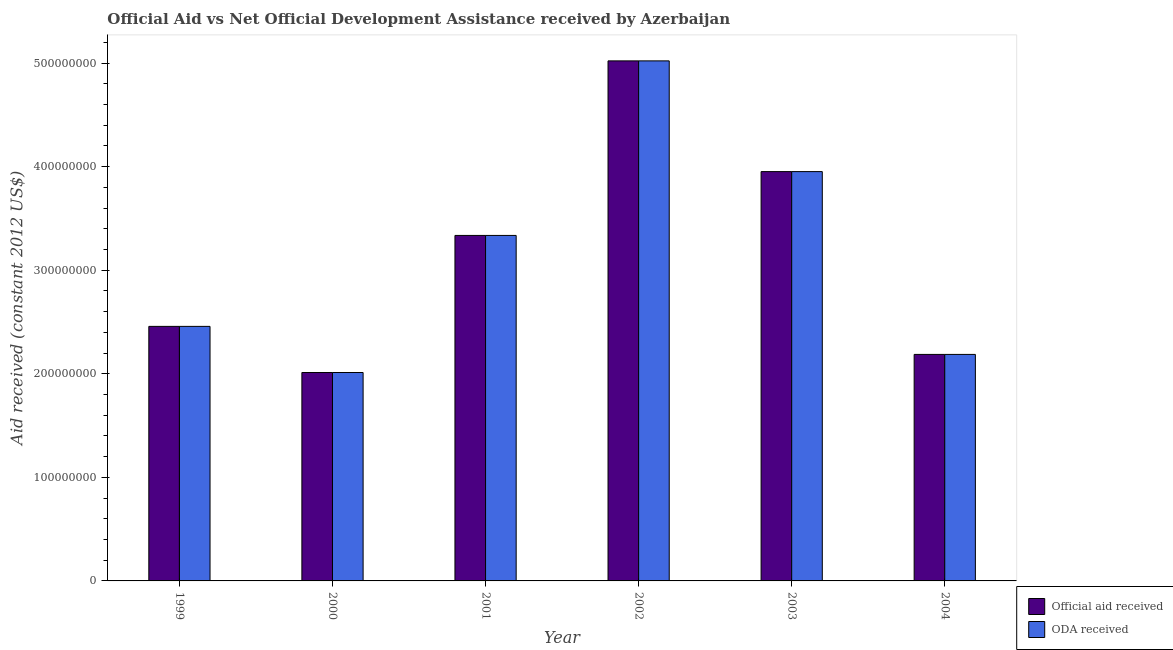How many different coloured bars are there?
Offer a very short reply. 2. How many groups of bars are there?
Provide a succinct answer. 6. Are the number of bars on each tick of the X-axis equal?
Your response must be concise. Yes. How many bars are there on the 5th tick from the left?
Your response must be concise. 2. What is the label of the 3rd group of bars from the left?
Offer a terse response. 2001. In how many cases, is the number of bars for a given year not equal to the number of legend labels?
Your answer should be compact. 0. What is the official aid received in 1999?
Ensure brevity in your answer.  2.46e+08. Across all years, what is the maximum oda received?
Your response must be concise. 5.02e+08. Across all years, what is the minimum official aid received?
Provide a short and direct response. 2.01e+08. In which year was the oda received maximum?
Ensure brevity in your answer.  2002. What is the total official aid received in the graph?
Your answer should be very brief. 1.90e+09. What is the difference between the oda received in 1999 and that in 2004?
Provide a short and direct response. 2.71e+07. What is the difference between the official aid received in 2000 and the oda received in 2001?
Your answer should be very brief. -1.32e+08. What is the average official aid received per year?
Give a very brief answer. 3.16e+08. In the year 2003, what is the difference between the official aid received and oda received?
Provide a succinct answer. 0. In how many years, is the official aid received greater than 160000000 US$?
Give a very brief answer. 6. What is the ratio of the official aid received in 2000 to that in 2001?
Give a very brief answer. 0.6. What is the difference between the highest and the second highest oda received?
Your response must be concise. 1.07e+08. What is the difference between the highest and the lowest official aid received?
Your answer should be compact. 3.01e+08. In how many years, is the oda received greater than the average oda received taken over all years?
Make the answer very short. 3. What does the 1st bar from the left in 2001 represents?
Provide a succinct answer. Official aid received. What does the 2nd bar from the right in 2001 represents?
Your response must be concise. Official aid received. What is the difference between two consecutive major ticks on the Y-axis?
Offer a terse response. 1.00e+08. Does the graph contain any zero values?
Give a very brief answer. No. Where does the legend appear in the graph?
Keep it short and to the point. Bottom right. What is the title of the graph?
Provide a succinct answer. Official Aid vs Net Official Development Assistance received by Azerbaijan . What is the label or title of the X-axis?
Keep it short and to the point. Year. What is the label or title of the Y-axis?
Ensure brevity in your answer.  Aid received (constant 2012 US$). What is the Aid received (constant 2012 US$) of Official aid received in 1999?
Make the answer very short. 2.46e+08. What is the Aid received (constant 2012 US$) of ODA received in 1999?
Your answer should be very brief. 2.46e+08. What is the Aid received (constant 2012 US$) of Official aid received in 2000?
Your response must be concise. 2.01e+08. What is the Aid received (constant 2012 US$) of ODA received in 2000?
Offer a terse response. 2.01e+08. What is the Aid received (constant 2012 US$) of Official aid received in 2001?
Your response must be concise. 3.34e+08. What is the Aid received (constant 2012 US$) in ODA received in 2001?
Keep it short and to the point. 3.34e+08. What is the Aid received (constant 2012 US$) in Official aid received in 2002?
Your answer should be very brief. 5.02e+08. What is the Aid received (constant 2012 US$) in ODA received in 2002?
Give a very brief answer. 5.02e+08. What is the Aid received (constant 2012 US$) in Official aid received in 2003?
Offer a terse response. 3.95e+08. What is the Aid received (constant 2012 US$) of ODA received in 2003?
Keep it short and to the point. 3.95e+08. What is the Aid received (constant 2012 US$) of Official aid received in 2004?
Provide a succinct answer. 2.19e+08. What is the Aid received (constant 2012 US$) in ODA received in 2004?
Make the answer very short. 2.19e+08. Across all years, what is the maximum Aid received (constant 2012 US$) in Official aid received?
Your answer should be compact. 5.02e+08. Across all years, what is the maximum Aid received (constant 2012 US$) of ODA received?
Provide a succinct answer. 5.02e+08. Across all years, what is the minimum Aid received (constant 2012 US$) of Official aid received?
Provide a succinct answer. 2.01e+08. Across all years, what is the minimum Aid received (constant 2012 US$) of ODA received?
Keep it short and to the point. 2.01e+08. What is the total Aid received (constant 2012 US$) in Official aid received in the graph?
Ensure brevity in your answer.  1.90e+09. What is the total Aid received (constant 2012 US$) of ODA received in the graph?
Keep it short and to the point. 1.90e+09. What is the difference between the Aid received (constant 2012 US$) in Official aid received in 1999 and that in 2000?
Offer a very short reply. 4.45e+07. What is the difference between the Aid received (constant 2012 US$) in ODA received in 1999 and that in 2000?
Provide a short and direct response. 4.45e+07. What is the difference between the Aid received (constant 2012 US$) in Official aid received in 1999 and that in 2001?
Your response must be concise. -8.78e+07. What is the difference between the Aid received (constant 2012 US$) of ODA received in 1999 and that in 2001?
Ensure brevity in your answer.  -8.78e+07. What is the difference between the Aid received (constant 2012 US$) of Official aid received in 1999 and that in 2002?
Your response must be concise. -2.56e+08. What is the difference between the Aid received (constant 2012 US$) in ODA received in 1999 and that in 2002?
Your response must be concise. -2.56e+08. What is the difference between the Aid received (constant 2012 US$) of Official aid received in 1999 and that in 2003?
Give a very brief answer. -1.49e+08. What is the difference between the Aid received (constant 2012 US$) of ODA received in 1999 and that in 2003?
Offer a very short reply. -1.49e+08. What is the difference between the Aid received (constant 2012 US$) of Official aid received in 1999 and that in 2004?
Give a very brief answer. 2.71e+07. What is the difference between the Aid received (constant 2012 US$) of ODA received in 1999 and that in 2004?
Keep it short and to the point. 2.71e+07. What is the difference between the Aid received (constant 2012 US$) of Official aid received in 2000 and that in 2001?
Ensure brevity in your answer.  -1.32e+08. What is the difference between the Aid received (constant 2012 US$) in ODA received in 2000 and that in 2001?
Give a very brief answer. -1.32e+08. What is the difference between the Aid received (constant 2012 US$) in Official aid received in 2000 and that in 2002?
Ensure brevity in your answer.  -3.01e+08. What is the difference between the Aid received (constant 2012 US$) of ODA received in 2000 and that in 2002?
Give a very brief answer. -3.01e+08. What is the difference between the Aid received (constant 2012 US$) of Official aid received in 2000 and that in 2003?
Your answer should be very brief. -1.94e+08. What is the difference between the Aid received (constant 2012 US$) of ODA received in 2000 and that in 2003?
Your answer should be very brief. -1.94e+08. What is the difference between the Aid received (constant 2012 US$) in Official aid received in 2000 and that in 2004?
Offer a very short reply. -1.75e+07. What is the difference between the Aid received (constant 2012 US$) of ODA received in 2000 and that in 2004?
Make the answer very short. -1.75e+07. What is the difference between the Aid received (constant 2012 US$) of Official aid received in 2001 and that in 2002?
Offer a very short reply. -1.69e+08. What is the difference between the Aid received (constant 2012 US$) in ODA received in 2001 and that in 2002?
Offer a terse response. -1.69e+08. What is the difference between the Aid received (constant 2012 US$) of Official aid received in 2001 and that in 2003?
Ensure brevity in your answer.  -6.16e+07. What is the difference between the Aid received (constant 2012 US$) of ODA received in 2001 and that in 2003?
Your answer should be very brief. -6.16e+07. What is the difference between the Aid received (constant 2012 US$) in Official aid received in 2001 and that in 2004?
Offer a terse response. 1.15e+08. What is the difference between the Aid received (constant 2012 US$) in ODA received in 2001 and that in 2004?
Your response must be concise. 1.15e+08. What is the difference between the Aid received (constant 2012 US$) in Official aid received in 2002 and that in 2003?
Ensure brevity in your answer.  1.07e+08. What is the difference between the Aid received (constant 2012 US$) of ODA received in 2002 and that in 2003?
Make the answer very short. 1.07e+08. What is the difference between the Aid received (constant 2012 US$) of Official aid received in 2002 and that in 2004?
Your answer should be very brief. 2.83e+08. What is the difference between the Aid received (constant 2012 US$) of ODA received in 2002 and that in 2004?
Offer a terse response. 2.83e+08. What is the difference between the Aid received (constant 2012 US$) of Official aid received in 2003 and that in 2004?
Ensure brevity in your answer.  1.77e+08. What is the difference between the Aid received (constant 2012 US$) in ODA received in 2003 and that in 2004?
Provide a short and direct response. 1.77e+08. What is the difference between the Aid received (constant 2012 US$) of Official aid received in 1999 and the Aid received (constant 2012 US$) of ODA received in 2000?
Your answer should be compact. 4.45e+07. What is the difference between the Aid received (constant 2012 US$) of Official aid received in 1999 and the Aid received (constant 2012 US$) of ODA received in 2001?
Your response must be concise. -8.78e+07. What is the difference between the Aid received (constant 2012 US$) in Official aid received in 1999 and the Aid received (constant 2012 US$) in ODA received in 2002?
Keep it short and to the point. -2.56e+08. What is the difference between the Aid received (constant 2012 US$) in Official aid received in 1999 and the Aid received (constant 2012 US$) in ODA received in 2003?
Ensure brevity in your answer.  -1.49e+08. What is the difference between the Aid received (constant 2012 US$) of Official aid received in 1999 and the Aid received (constant 2012 US$) of ODA received in 2004?
Offer a terse response. 2.71e+07. What is the difference between the Aid received (constant 2012 US$) in Official aid received in 2000 and the Aid received (constant 2012 US$) in ODA received in 2001?
Offer a terse response. -1.32e+08. What is the difference between the Aid received (constant 2012 US$) in Official aid received in 2000 and the Aid received (constant 2012 US$) in ODA received in 2002?
Your answer should be very brief. -3.01e+08. What is the difference between the Aid received (constant 2012 US$) in Official aid received in 2000 and the Aid received (constant 2012 US$) in ODA received in 2003?
Give a very brief answer. -1.94e+08. What is the difference between the Aid received (constant 2012 US$) of Official aid received in 2000 and the Aid received (constant 2012 US$) of ODA received in 2004?
Your response must be concise. -1.75e+07. What is the difference between the Aid received (constant 2012 US$) of Official aid received in 2001 and the Aid received (constant 2012 US$) of ODA received in 2002?
Ensure brevity in your answer.  -1.69e+08. What is the difference between the Aid received (constant 2012 US$) in Official aid received in 2001 and the Aid received (constant 2012 US$) in ODA received in 2003?
Give a very brief answer. -6.16e+07. What is the difference between the Aid received (constant 2012 US$) of Official aid received in 2001 and the Aid received (constant 2012 US$) of ODA received in 2004?
Offer a terse response. 1.15e+08. What is the difference between the Aid received (constant 2012 US$) in Official aid received in 2002 and the Aid received (constant 2012 US$) in ODA received in 2003?
Your answer should be compact. 1.07e+08. What is the difference between the Aid received (constant 2012 US$) of Official aid received in 2002 and the Aid received (constant 2012 US$) of ODA received in 2004?
Give a very brief answer. 2.83e+08. What is the difference between the Aid received (constant 2012 US$) of Official aid received in 2003 and the Aid received (constant 2012 US$) of ODA received in 2004?
Provide a short and direct response. 1.77e+08. What is the average Aid received (constant 2012 US$) in Official aid received per year?
Provide a succinct answer. 3.16e+08. What is the average Aid received (constant 2012 US$) in ODA received per year?
Make the answer very short. 3.16e+08. What is the ratio of the Aid received (constant 2012 US$) of Official aid received in 1999 to that in 2000?
Give a very brief answer. 1.22. What is the ratio of the Aid received (constant 2012 US$) of ODA received in 1999 to that in 2000?
Your response must be concise. 1.22. What is the ratio of the Aid received (constant 2012 US$) of Official aid received in 1999 to that in 2001?
Provide a short and direct response. 0.74. What is the ratio of the Aid received (constant 2012 US$) of ODA received in 1999 to that in 2001?
Your answer should be very brief. 0.74. What is the ratio of the Aid received (constant 2012 US$) in Official aid received in 1999 to that in 2002?
Offer a terse response. 0.49. What is the ratio of the Aid received (constant 2012 US$) of ODA received in 1999 to that in 2002?
Offer a very short reply. 0.49. What is the ratio of the Aid received (constant 2012 US$) in Official aid received in 1999 to that in 2003?
Your answer should be very brief. 0.62. What is the ratio of the Aid received (constant 2012 US$) of ODA received in 1999 to that in 2003?
Provide a short and direct response. 0.62. What is the ratio of the Aid received (constant 2012 US$) of Official aid received in 1999 to that in 2004?
Your answer should be very brief. 1.12. What is the ratio of the Aid received (constant 2012 US$) in ODA received in 1999 to that in 2004?
Your answer should be very brief. 1.12. What is the ratio of the Aid received (constant 2012 US$) in Official aid received in 2000 to that in 2001?
Your answer should be very brief. 0.6. What is the ratio of the Aid received (constant 2012 US$) of ODA received in 2000 to that in 2001?
Offer a very short reply. 0.6. What is the ratio of the Aid received (constant 2012 US$) in Official aid received in 2000 to that in 2002?
Give a very brief answer. 0.4. What is the ratio of the Aid received (constant 2012 US$) in ODA received in 2000 to that in 2002?
Your answer should be compact. 0.4. What is the ratio of the Aid received (constant 2012 US$) in Official aid received in 2000 to that in 2003?
Give a very brief answer. 0.51. What is the ratio of the Aid received (constant 2012 US$) of ODA received in 2000 to that in 2003?
Provide a short and direct response. 0.51. What is the ratio of the Aid received (constant 2012 US$) of Official aid received in 2000 to that in 2004?
Provide a short and direct response. 0.92. What is the ratio of the Aid received (constant 2012 US$) of ODA received in 2000 to that in 2004?
Make the answer very short. 0.92. What is the ratio of the Aid received (constant 2012 US$) of Official aid received in 2001 to that in 2002?
Your answer should be very brief. 0.66. What is the ratio of the Aid received (constant 2012 US$) in ODA received in 2001 to that in 2002?
Your answer should be compact. 0.66. What is the ratio of the Aid received (constant 2012 US$) of Official aid received in 2001 to that in 2003?
Provide a short and direct response. 0.84. What is the ratio of the Aid received (constant 2012 US$) of ODA received in 2001 to that in 2003?
Keep it short and to the point. 0.84. What is the ratio of the Aid received (constant 2012 US$) in Official aid received in 2001 to that in 2004?
Ensure brevity in your answer.  1.53. What is the ratio of the Aid received (constant 2012 US$) in ODA received in 2001 to that in 2004?
Ensure brevity in your answer.  1.53. What is the ratio of the Aid received (constant 2012 US$) of Official aid received in 2002 to that in 2003?
Give a very brief answer. 1.27. What is the ratio of the Aid received (constant 2012 US$) of ODA received in 2002 to that in 2003?
Keep it short and to the point. 1.27. What is the ratio of the Aid received (constant 2012 US$) of Official aid received in 2002 to that in 2004?
Give a very brief answer. 2.3. What is the ratio of the Aid received (constant 2012 US$) of ODA received in 2002 to that in 2004?
Ensure brevity in your answer.  2.3. What is the ratio of the Aid received (constant 2012 US$) of Official aid received in 2003 to that in 2004?
Ensure brevity in your answer.  1.81. What is the ratio of the Aid received (constant 2012 US$) of ODA received in 2003 to that in 2004?
Give a very brief answer. 1.81. What is the difference between the highest and the second highest Aid received (constant 2012 US$) of Official aid received?
Your answer should be very brief. 1.07e+08. What is the difference between the highest and the second highest Aid received (constant 2012 US$) in ODA received?
Provide a succinct answer. 1.07e+08. What is the difference between the highest and the lowest Aid received (constant 2012 US$) in Official aid received?
Your response must be concise. 3.01e+08. What is the difference between the highest and the lowest Aid received (constant 2012 US$) of ODA received?
Offer a terse response. 3.01e+08. 